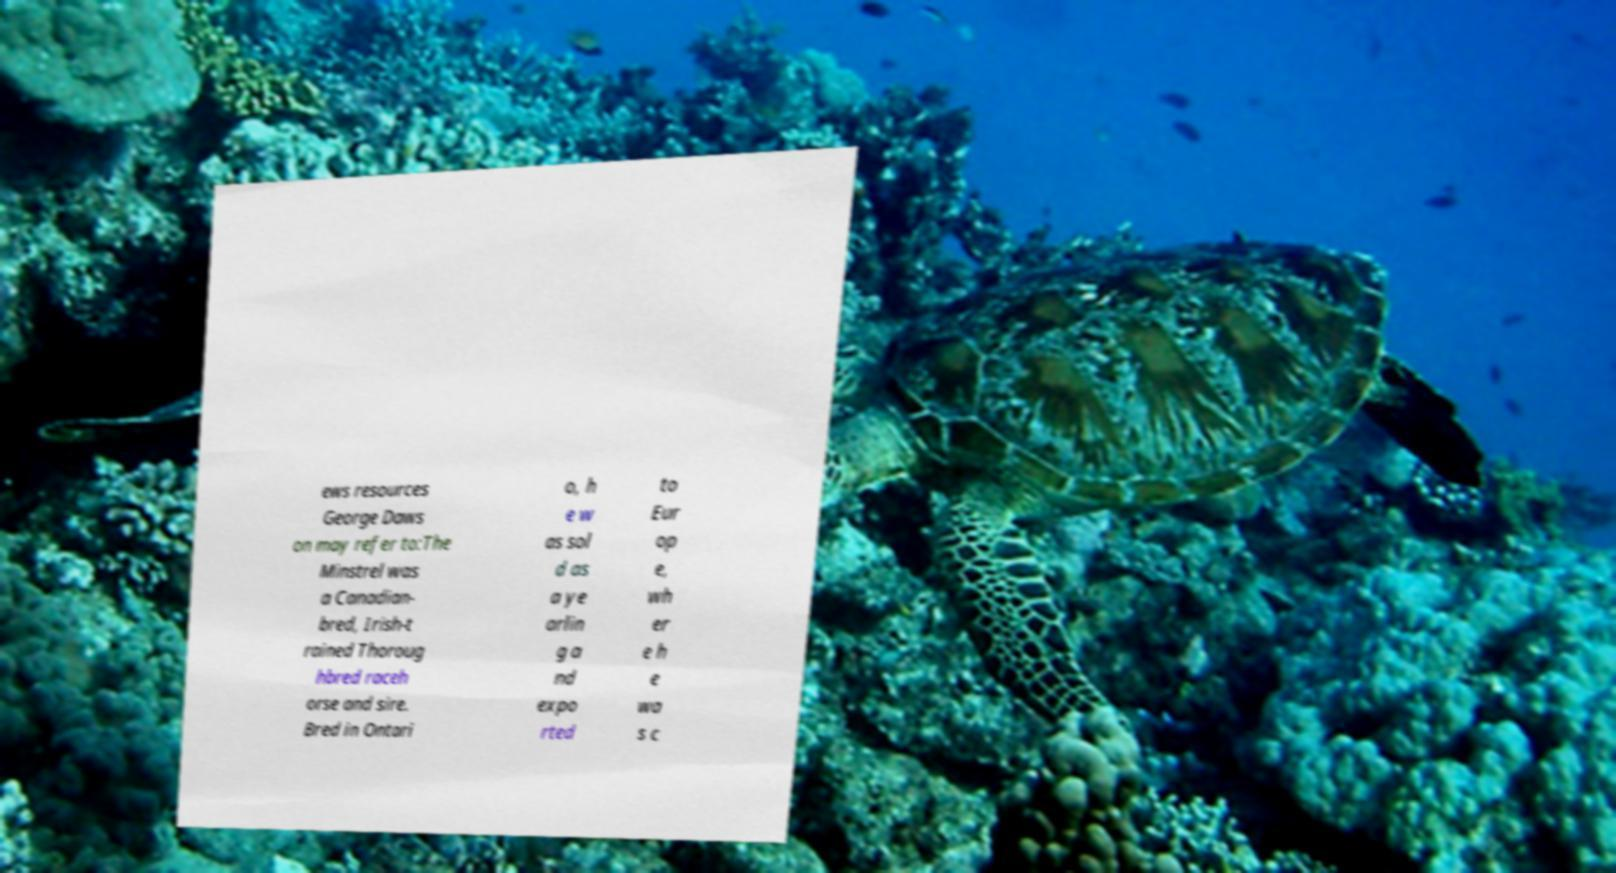Please read and relay the text visible in this image. What does it say? ews resources George Daws on may refer to:The Minstrel was a Canadian- bred, Irish-t rained Thoroug hbred raceh orse and sire. Bred in Ontari o, h e w as sol d as a ye arlin g a nd expo rted to Eur op e, wh er e h e wa s c 